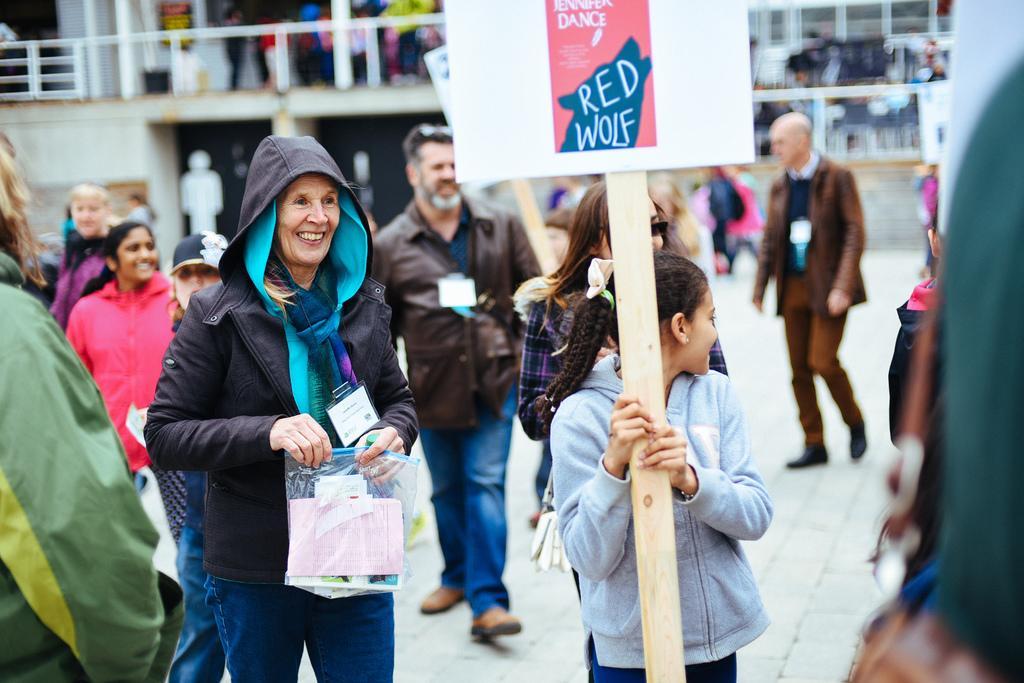Could you give a brief overview of what you see in this image? Here we can see few persons are standing and walking on the road and among them few are holding hoarding board poles and a packet. In the background the image is blur we can see fences, few persons standing on the floor and other objects. 